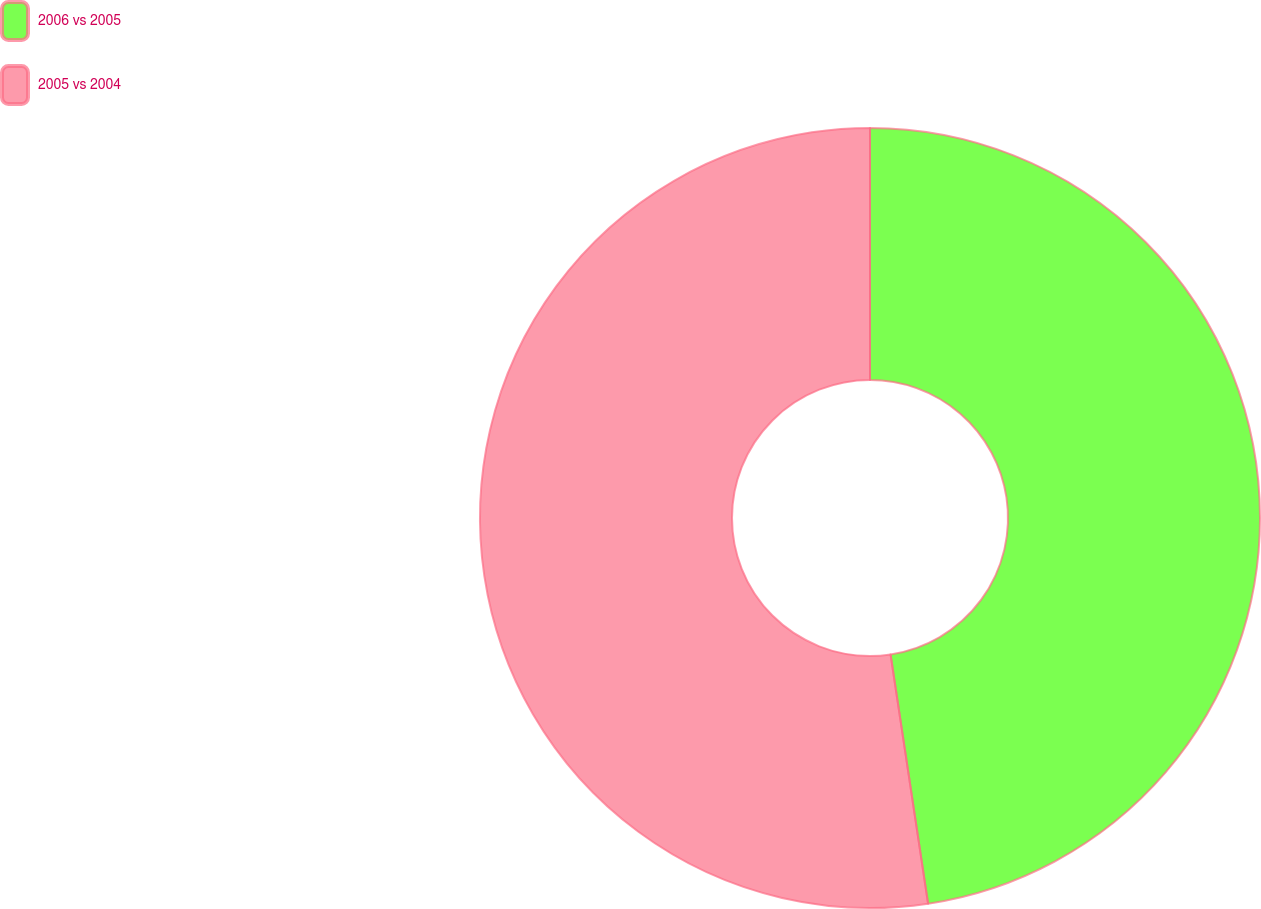Convert chart to OTSL. <chart><loc_0><loc_0><loc_500><loc_500><pie_chart><fcel>2006 vs 2005<fcel>2005 vs 2004<nl><fcel>47.62%<fcel>52.38%<nl></chart> 